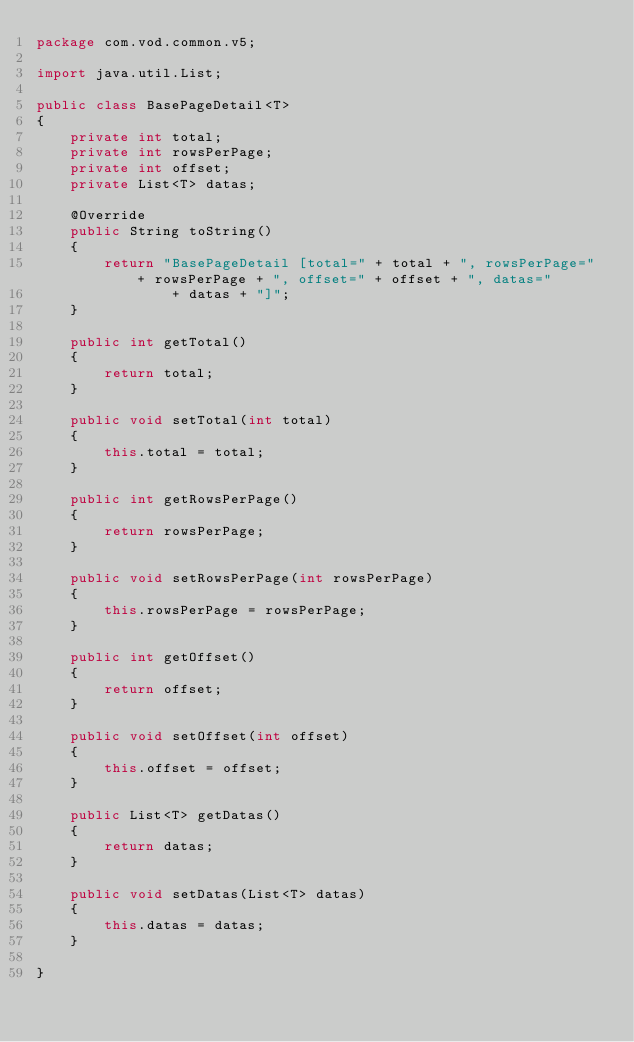Convert code to text. <code><loc_0><loc_0><loc_500><loc_500><_Java_>package com.vod.common.v5;

import java.util.List;

public class BasePageDetail<T>
{
    private int total;
    private int rowsPerPage;
    private int offset;
    private List<T> datas;

    @Override
    public String toString()
    {
        return "BasePageDetail [total=" + total + ", rowsPerPage=" + rowsPerPage + ", offset=" + offset + ", datas="
                + datas + "]";
    }

    public int getTotal()
    {
        return total;
    }

    public void setTotal(int total)
    {
        this.total = total;
    }

    public int getRowsPerPage()
    {
        return rowsPerPage;
    }

    public void setRowsPerPage(int rowsPerPage)
    {
        this.rowsPerPage = rowsPerPage;
    }

    public int getOffset()
    {
        return offset;
    }

    public void setOffset(int offset)
    {
        this.offset = offset;
    }

    public List<T> getDatas()
    {
        return datas;
    }

    public void setDatas(List<T> datas)
    {
        this.datas = datas;
    }

}
</code> 